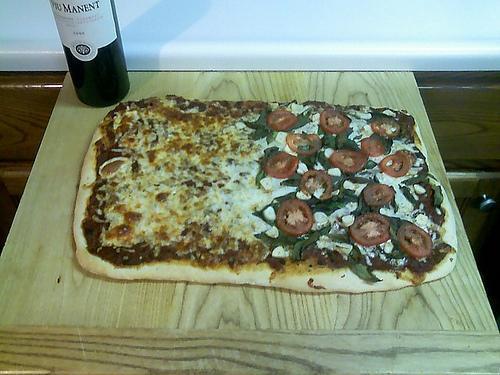How many wine bottles are there?
Give a very brief answer. 1. How many toppings are there?
Give a very brief answer. 4. 